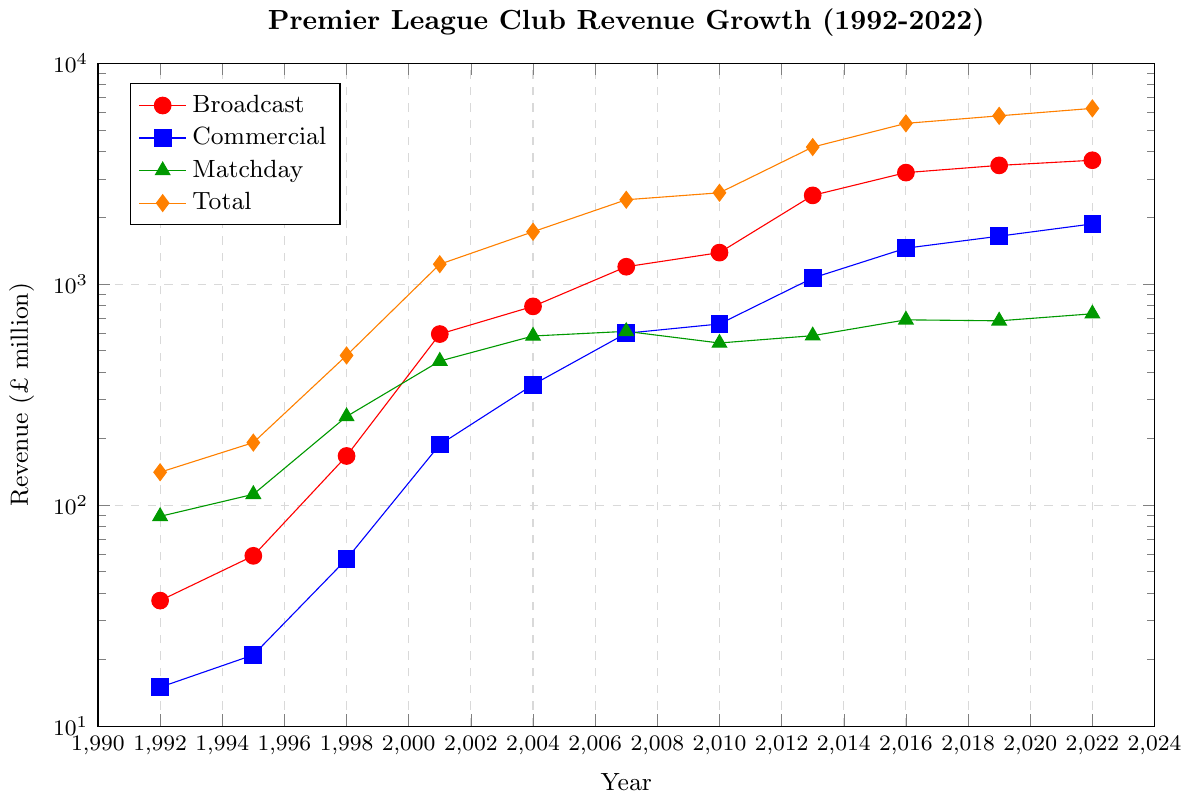What's the highest revenue source category in 2022? By examining the visual height of the data points in 2022, we see that the category with the highest value is "Broadcast".
Answer: Broadcast How much did the total revenue grow from 1992 to 2022? To find the growth, we subtract the total revenue in 1992 from the total revenue in 2022. From the chart, Total revenue values are 6250 (2022) and 141 (1992). So, 6250 - 141 = 6109.
Answer: 6109 Which revenue source category showed the least growth from 2019 to 2022? Comparing the heights of the data points in each category between 2019 and 2022, "Matchday" revenue has the smallest increase, from 683 to 735.
Answer: Matchday In which year did commercial revenue first surpass £500 million? Checking the values on the Commercial revenue plot line, we see that it first surpasses £500 million in 2007 with a value of £600 million.
Answer: 2007 What's the total increase in broadcast revenue from 1992 to 2001? Identify the Broadcast revenue values in 1992 and 2001 from the chart. They are 37 and 595 respectively. Subtract 1992 value from 2001 value: 595 - 37 = 558.
Answer: 558 Which category had the most significant proportional increase between 1995 and 1998? Calculate the proportional increase for each category from 1995 to 1998: 
- Broadcast: (167-59)/59 = 1.83
- Commercial: (57-21)/21 = 1.71
- Matchday: (252-112)/112 = 1.25
- Total: (476-192)/192 = 1.48
Broadcast has the highest proportional increase.
Answer: Broadcast How many times did Commercial revenue increase from 1998 to 2019? The Commercial revenue in 1998 was £57 million and in 2019 it was £1650 million. Divide the 2019 value by the 1998 value: 1650 / 57 ≈ 28.95.
Answer: ~29 times By what factor did Total revenue increase between 2004 and 2019? Total revenue in 2004 was £1728 million and in 2019 was £5783 million. Divide 2019 value by 2004 value: 5783 / 1728 ≈ 3.35.
Answer: ~3.35 Which revenue source is represented by green markers? By matching the color listed in the legend to the plot, the category with green markers is "Matchday".
Answer: Matchday In what year did broadcast revenue exceed £1000 million for the first time? The chart shows that Broadcast revenue first exceeds £1000 million in 2007 where the value is £1200 million.
Answer: 2007 